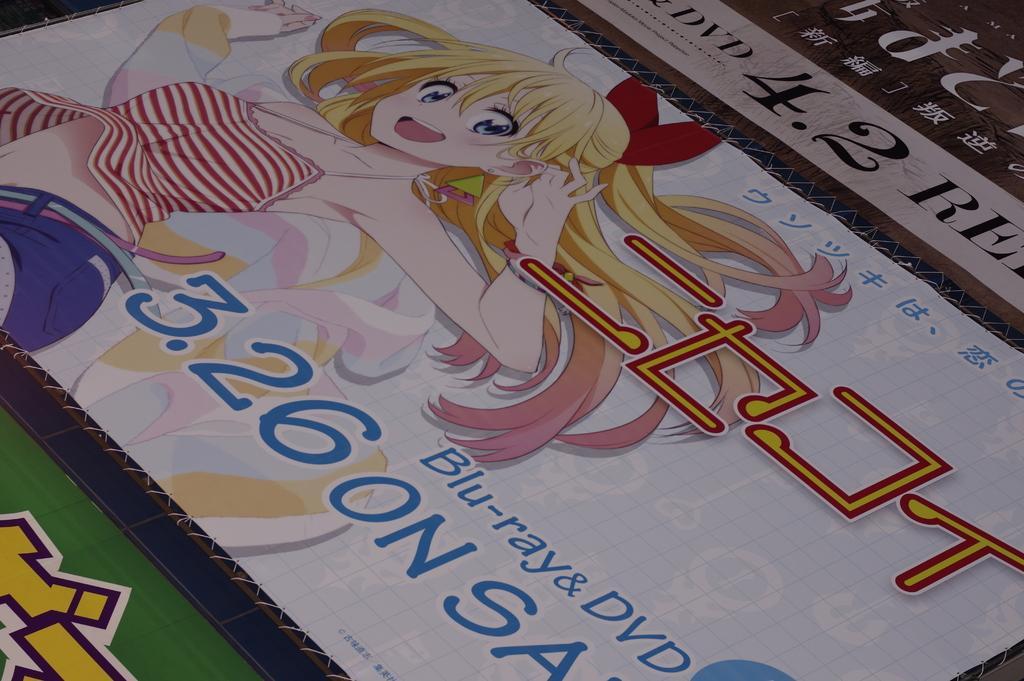Could you give a brief overview of what you see in this image? In the image we can see a banner. 